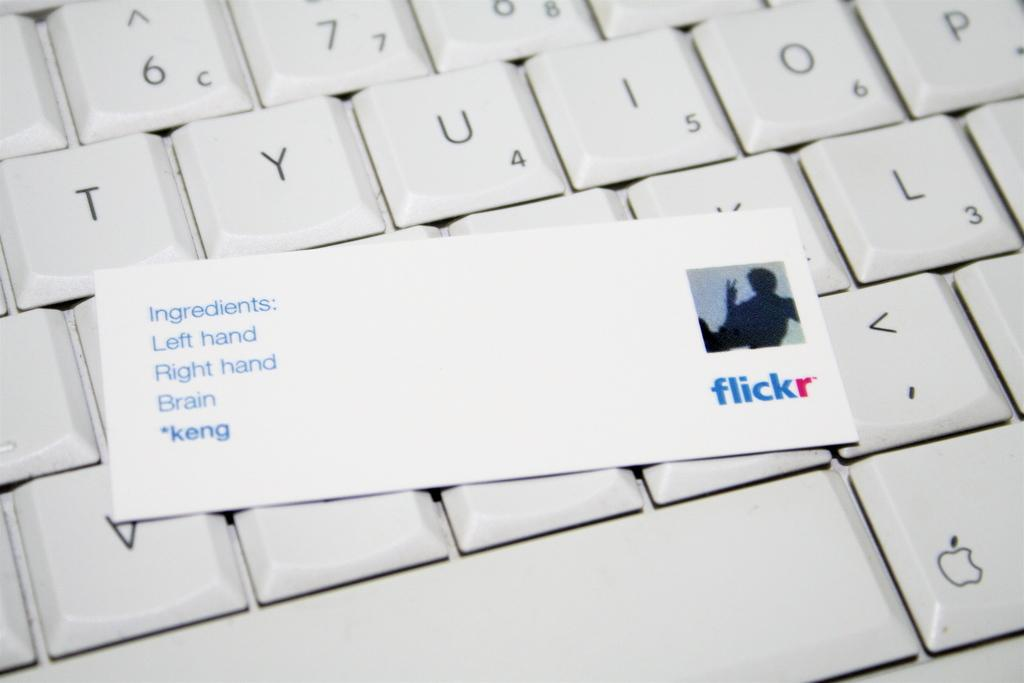<image>
Render a clear and concise summary of the photo. A white keyboard with a Flickr laying on top of the keyboard. 